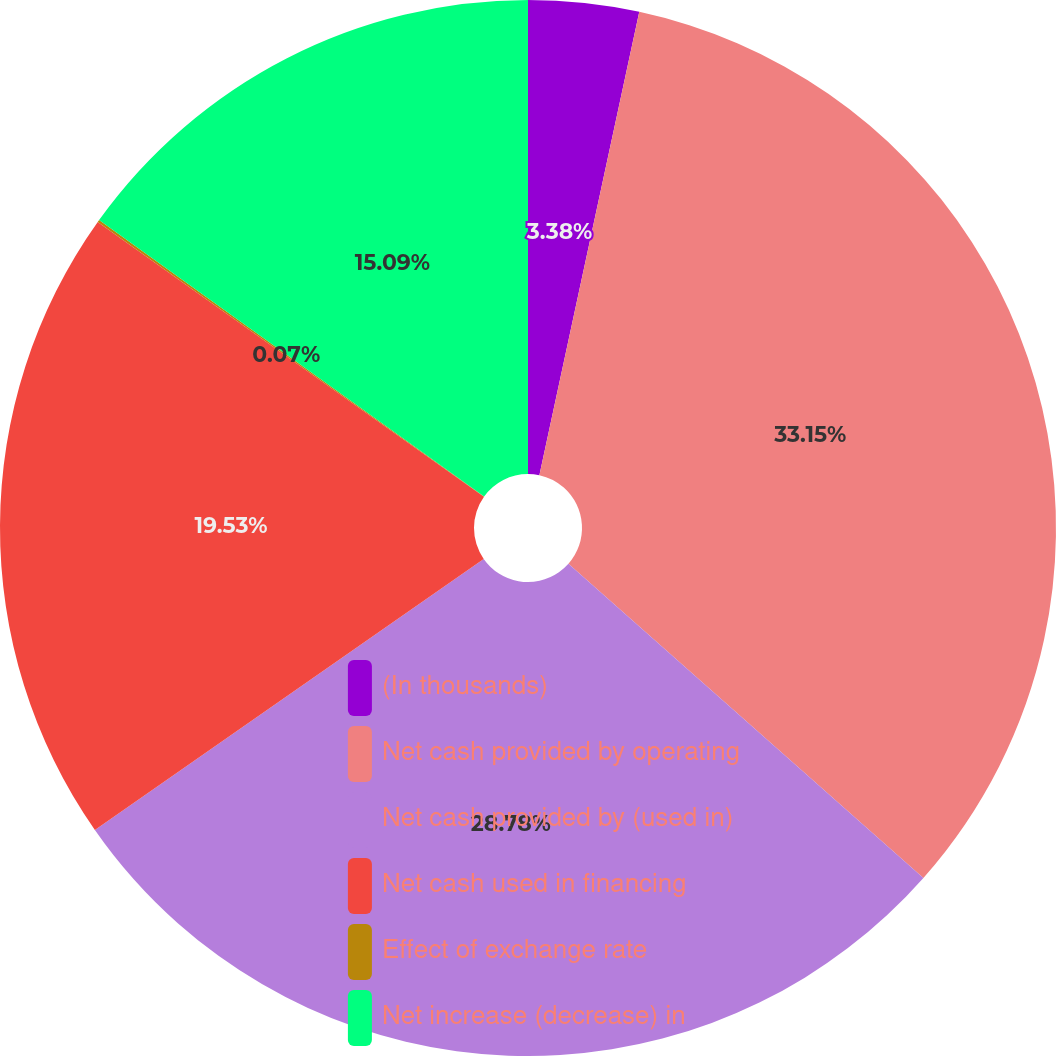Convert chart to OTSL. <chart><loc_0><loc_0><loc_500><loc_500><pie_chart><fcel>(In thousands)<fcel>Net cash provided by operating<fcel>Net cash provided by (used in)<fcel>Net cash used in financing<fcel>Effect of exchange rate<fcel>Net increase (decrease) in<nl><fcel>3.38%<fcel>33.15%<fcel>28.78%<fcel>19.53%<fcel>0.07%<fcel>15.09%<nl></chart> 